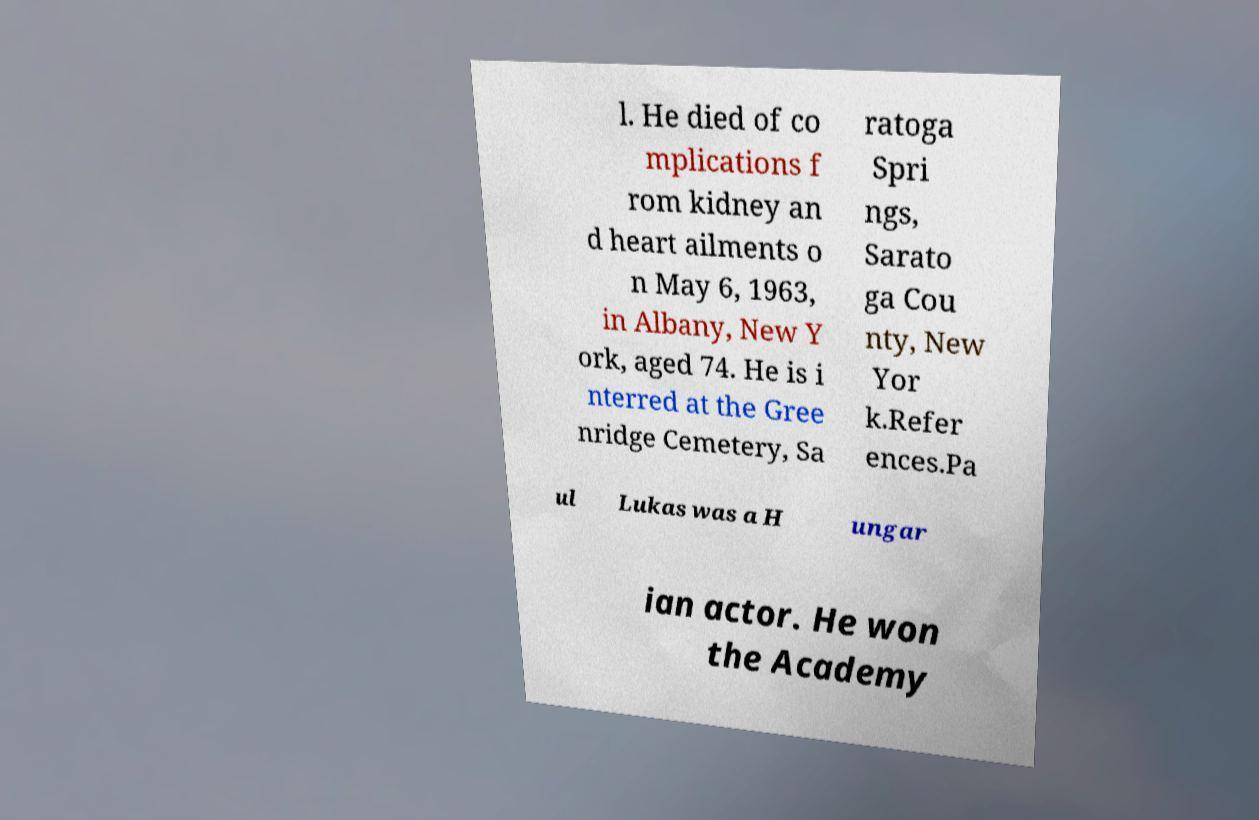Please read and relay the text visible in this image. What does it say? l. He died of co mplications f rom kidney an d heart ailments o n May 6, 1963, in Albany, New Y ork, aged 74. He is i nterred at the Gree nridge Cemetery, Sa ratoga Spri ngs, Sarato ga Cou nty, New Yor k.Refer ences.Pa ul Lukas was a H ungar ian actor. He won the Academy 